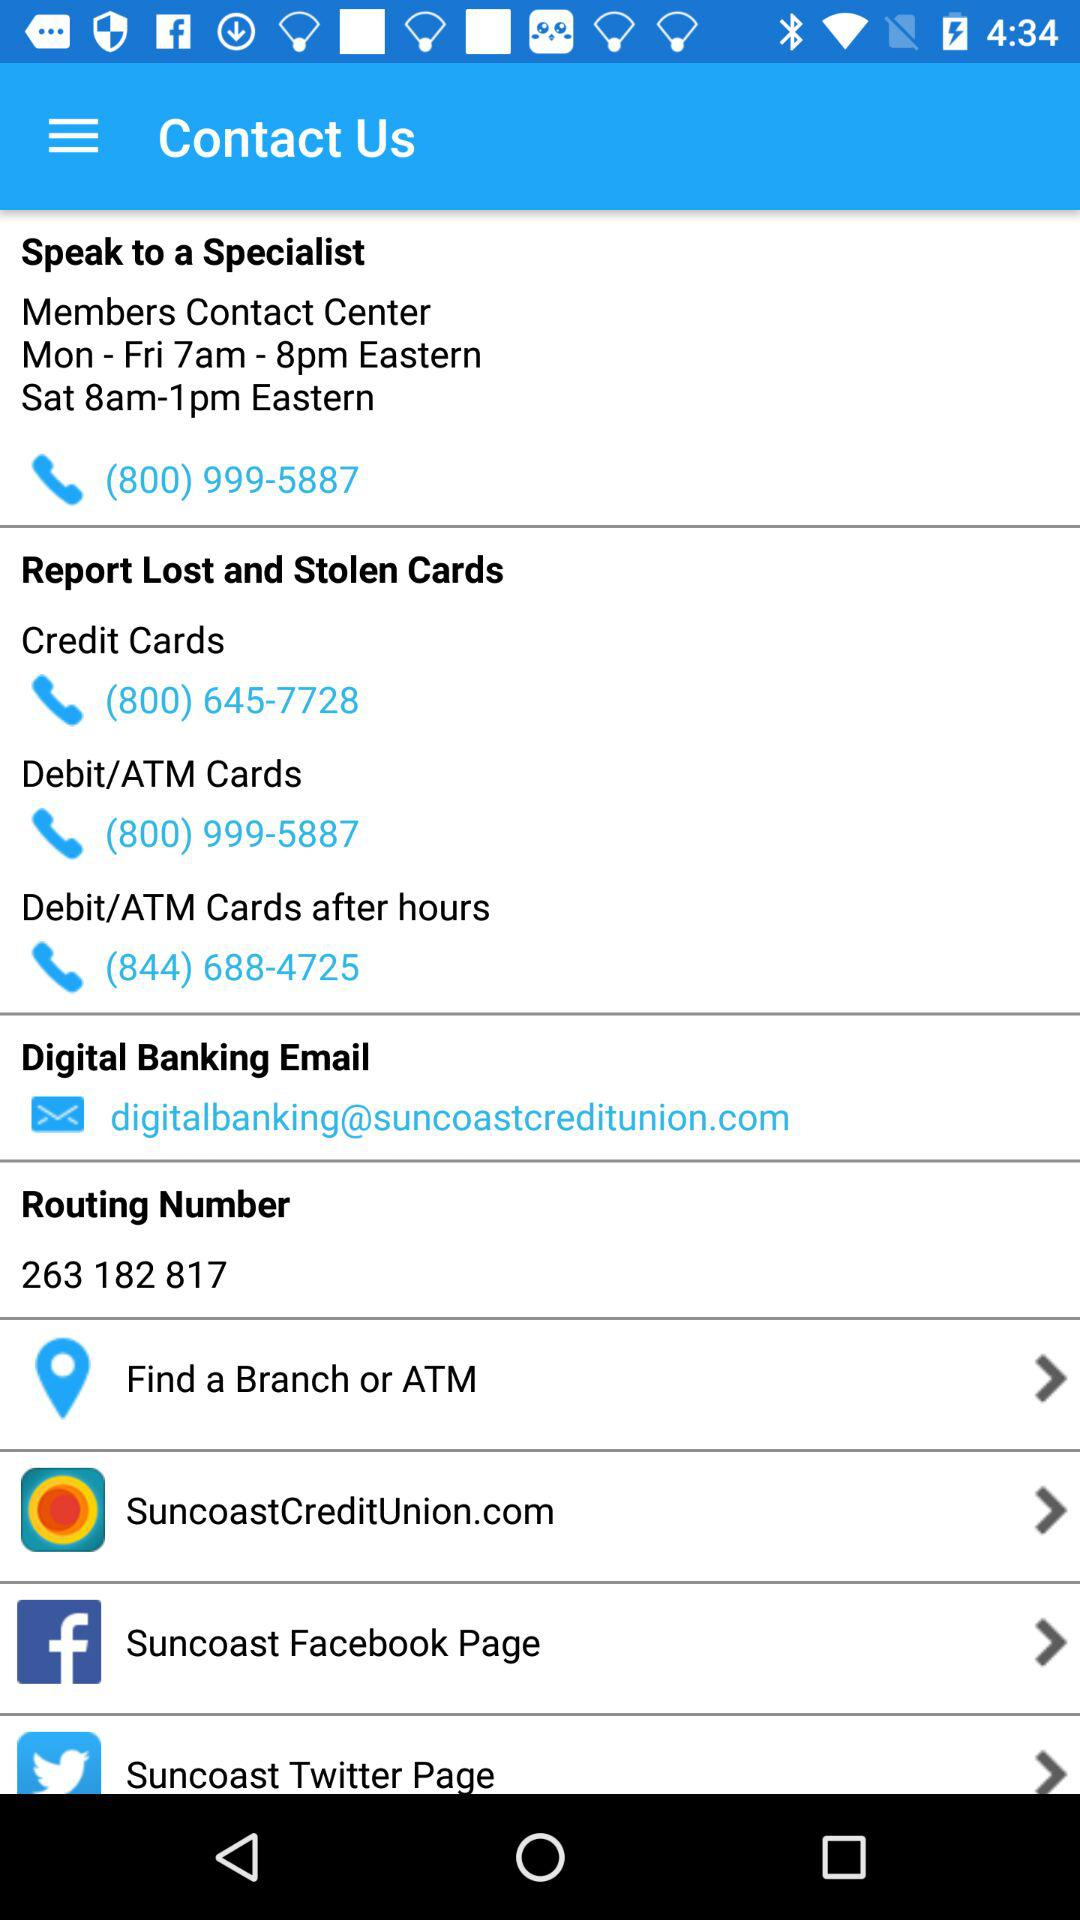What is the email address? The email address is digitalbanking@suncoastcreditunion.com. 